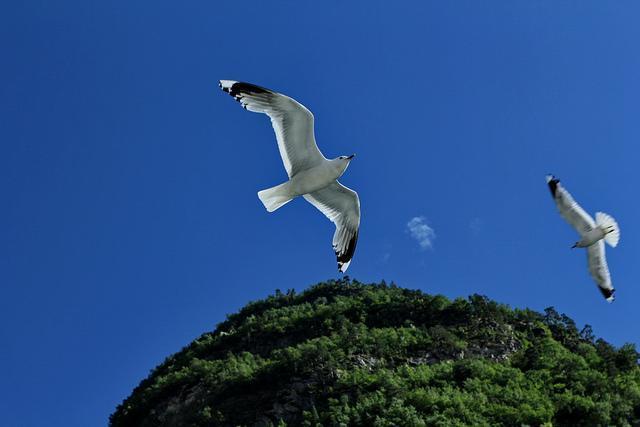How many clouds are in the sky?
Give a very brief answer. 1. How many birds are in the photo?
Give a very brief answer. 2. 